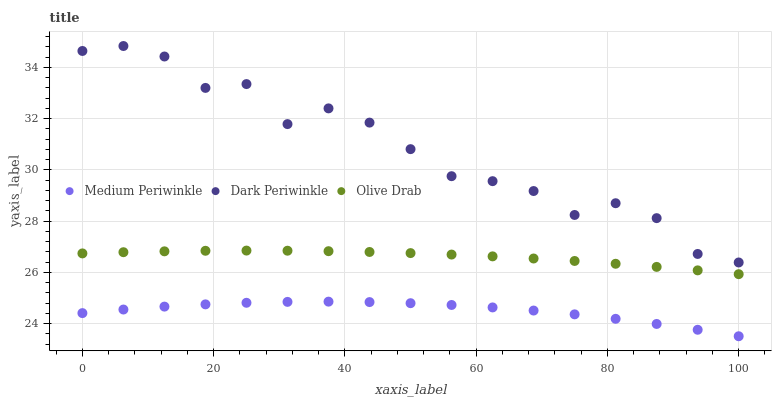Does Medium Periwinkle have the minimum area under the curve?
Answer yes or no. Yes. Does Dark Periwinkle have the maximum area under the curve?
Answer yes or no. Yes. Does Olive Drab have the minimum area under the curve?
Answer yes or no. No. Does Olive Drab have the maximum area under the curve?
Answer yes or no. No. Is Olive Drab the smoothest?
Answer yes or no. Yes. Is Dark Periwinkle the roughest?
Answer yes or no. Yes. Is Dark Periwinkle the smoothest?
Answer yes or no. No. Is Olive Drab the roughest?
Answer yes or no. No. Does Medium Periwinkle have the lowest value?
Answer yes or no. Yes. Does Olive Drab have the lowest value?
Answer yes or no. No. Does Dark Periwinkle have the highest value?
Answer yes or no. Yes. Does Olive Drab have the highest value?
Answer yes or no. No. Is Olive Drab less than Dark Periwinkle?
Answer yes or no. Yes. Is Dark Periwinkle greater than Medium Periwinkle?
Answer yes or no. Yes. Does Olive Drab intersect Dark Periwinkle?
Answer yes or no. No. 